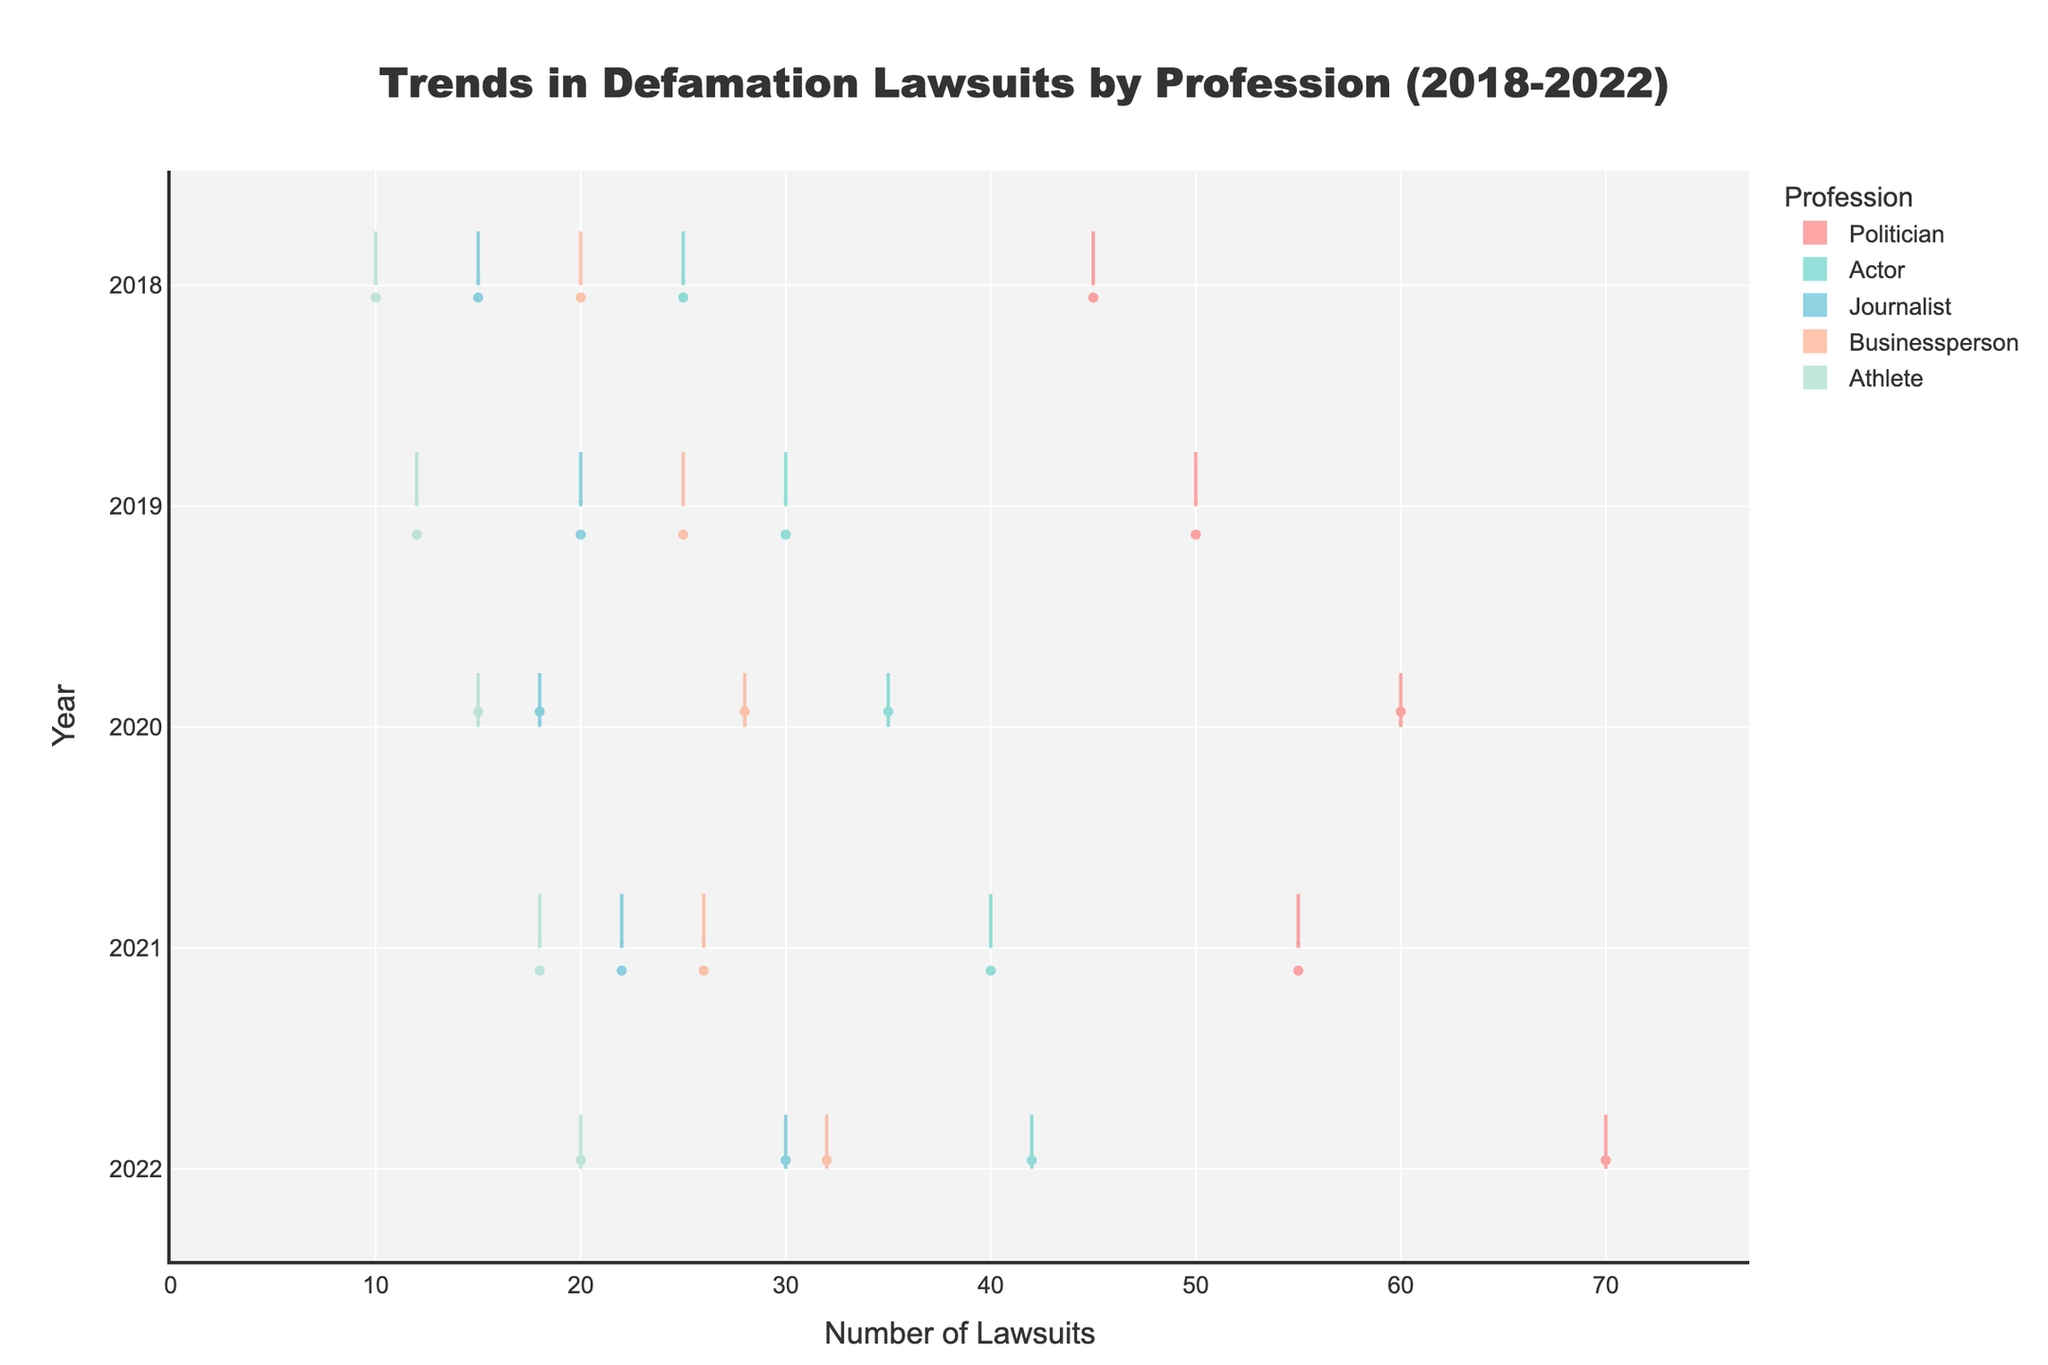Which profession filed the highest number of defamation lawsuits in 2022? By looking at the violin chart for the year 2022, we can see that the profession with the highest count is the politician, with 70 lawsuits filed.
Answer: Politician What general trend can you observe for defamation lawsuits filed by journalists from 2018 to 2022? Observing the data points for journalists across the years, there is a noticeable upward trend, beginning with 15 lawsuits in 2018 and increasing to 30 lawsuits by 2022.
Answer: Upward trend How many more defamation lawsuits were filed by actors than athletes in 2021? The number of lawsuits filed by actors in 2021 is 40, and the number filed by athletes is 18. Subtracting these gives: 40 - 18 = 22.
Answer: 22 Which year saw the highest number of defamation lawsuits filed by businesspersons? By looking at the spread and the central data points in the violin chart for businesspersons, it is clear that 2022 saw the highest number with 32 lawsuits filed.
Answer: 2022 By how much did the number of defamation lawsuits filed by politicians increase from 2018 to 2022? In 2018, politicians filed 45 lawsuits, and in 2022, they filed 70. The increase is: 70 - 45 = 25.
Answer: 25 Which profession shows the most significant increase in defamation lawsuits filed between 2018 and 2022? Comparing the counts from 2018 to 2022 for each profession, journalists increased by 15, businesspersons by 12, athletes by 10, actors by 17, and politicians by 25. The largest increase is for politicians.
Answer: Politicians In which year did athletes see the smallest number of defamation lawsuits filed? The athletes filed the fewest lawsuits in 2018, with only 10 cases reported.
Answer: 2018 How does the midpoint (average) of defamation lawsuits filed by politicians in 2018 compare to that of actors in 2020? For politicians in 2018: 45 lawsuits. For actors in 2020: 35 lawsuits. The midpoint (average) is comparative, showing that politicians filed more lawsuits on average.
Answer: Politicians filed more Do the violin plots for businesspersons and athletes overlap in 2020, and what does this suggest about their lawsuit counts? Yes, the ranges of lawsuits filed by businesspersons (28) and athletes (15) do overlap, suggesting their counts were close but not identical, as both had some spread that leads to a visual overlap.
Answer: Yes, they overlap Looking solely at 2019, compare the number of lawsuits between actors and journalists. In 2019, actors filed 30 lawsuits, and journalists filed 20, thus actors filed 10 more lawsuits than journalists.
Answer: Actors filed 10 more 